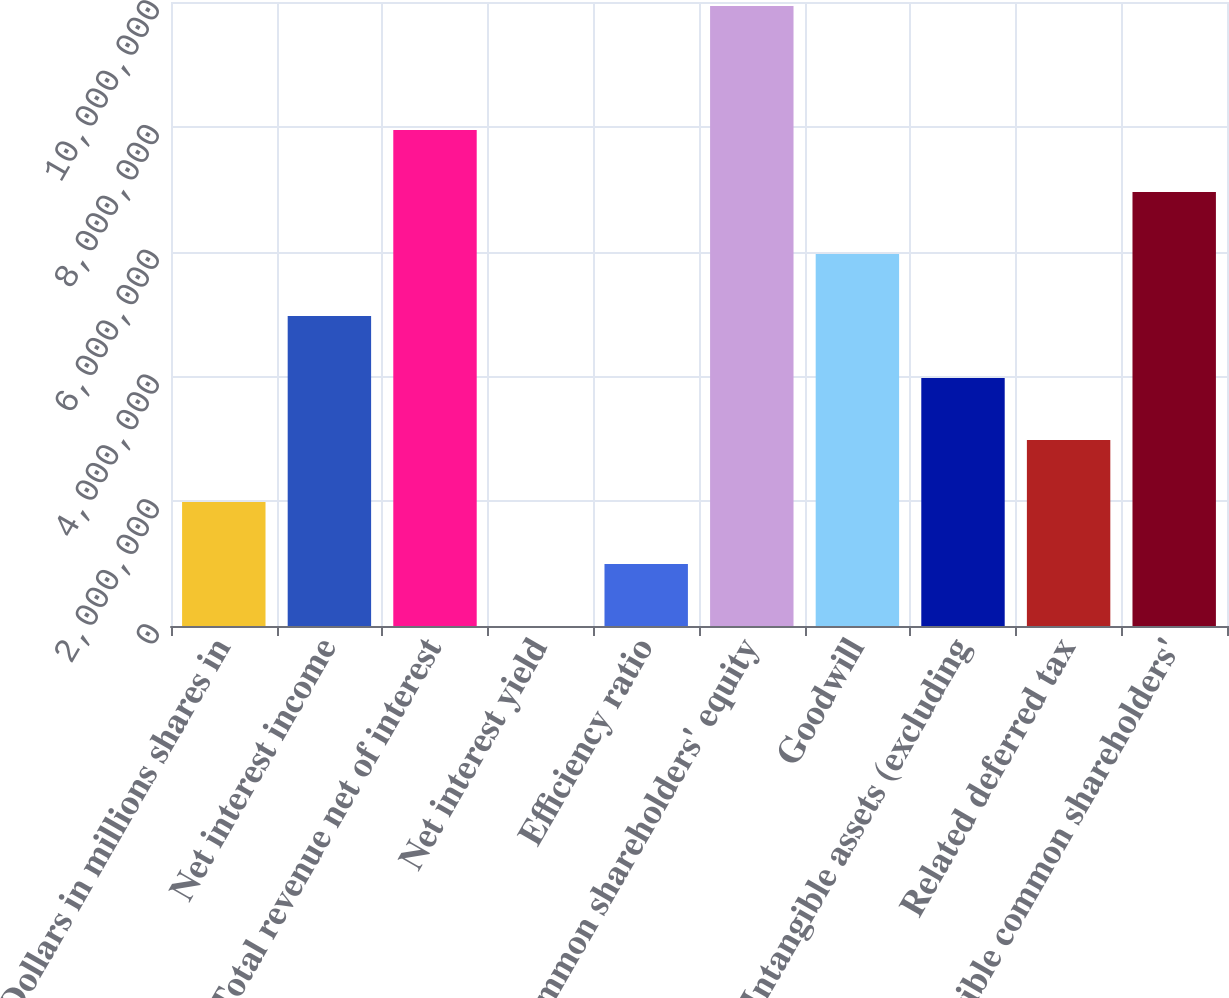Convert chart. <chart><loc_0><loc_0><loc_500><loc_500><bar_chart><fcel>(Dollars in millions shares in<fcel>Net interest income<fcel>Total revenue net of interest<fcel>Net interest yield<fcel>Efficiency ratio<fcel>Common shareholders' equity<fcel>Goodwill<fcel>Intangible assets (excluding<fcel>Related deferred tax<fcel>Tangible common shareholders'<nl><fcel>1.98725e+06<fcel>4.96812e+06<fcel>7.949e+06<fcel>2.65<fcel>993627<fcel>9.93624e+06<fcel>5.96175e+06<fcel>3.9745e+06<fcel>2.98088e+06<fcel>6.95537e+06<nl></chart> 